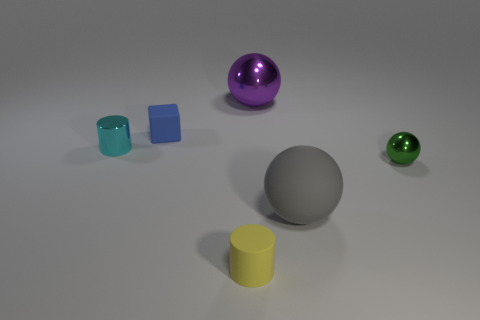The small metal thing that is to the left of the tiny metallic thing on the right side of the cylinder that is behind the yellow cylinder is what shape?
Offer a very short reply. Cylinder. Is there anything else that is the same shape as the blue matte object?
Offer a terse response. No. What number of spheres are either small yellow matte objects or large blue matte things?
Provide a short and direct response. 0. There is a rubber object to the left of the yellow cylinder; is it the same color as the shiny cylinder?
Ensure brevity in your answer.  No. The cylinder that is to the right of the metallic object that is on the left side of the large thing that is behind the blue object is made of what material?
Your answer should be very brief. Rubber. Is the size of the gray thing the same as the green object?
Make the answer very short. No. There is a big rubber object; is its color the same as the sphere that is to the left of the big rubber thing?
Make the answer very short. No. There is a large gray object that is made of the same material as the blue object; what shape is it?
Your response must be concise. Sphere. There is a small rubber thing behind the yellow thing; is it the same shape as the gray thing?
Make the answer very short. No. How big is the metal thing that is left of the rubber thing that is to the left of the yellow rubber cylinder?
Provide a short and direct response. Small. 